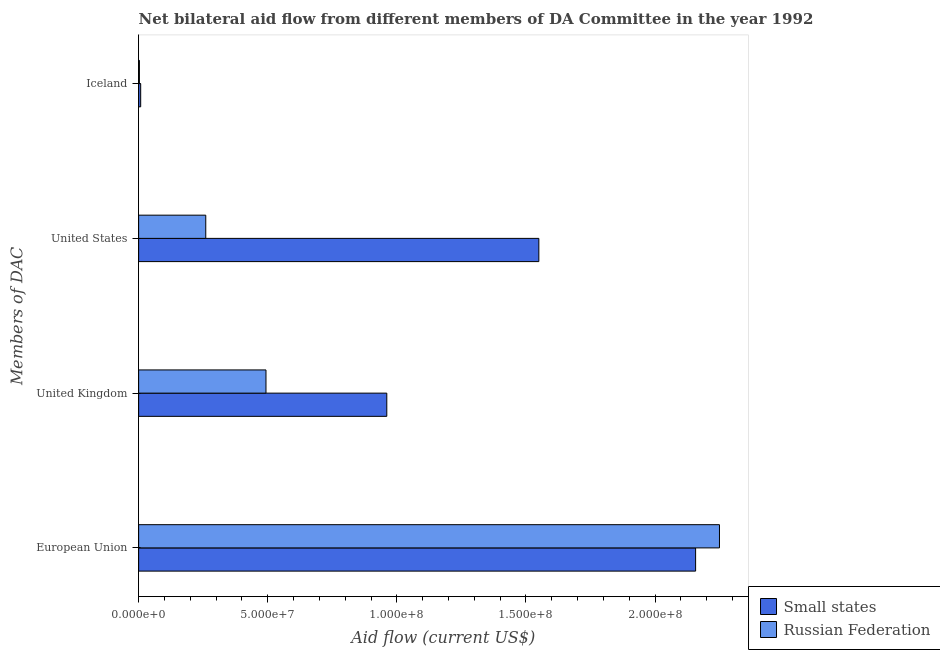How many groups of bars are there?
Ensure brevity in your answer.  4. Are the number of bars on each tick of the Y-axis equal?
Keep it short and to the point. Yes. How many bars are there on the 2nd tick from the top?
Keep it short and to the point. 2. What is the label of the 1st group of bars from the top?
Provide a short and direct response. Iceland. What is the amount of aid given by uk in Russian Federation?
Offer a very short reply. 4.93e+07. Across all countries, what is the maximum amount of aid given by iceland?
Provide a succinct answer. 8.00e+05. Across all countries, what is the minimum amount of aid given by uk?
Your response must be concise. 4.93e+07. In which country was the amount of aid given by eu maximum?
Your answer should be compact. Russian Federation. In which country was the amount of aid given by uk minimum?
Give a very brief answer. Russian Federation. What is the total amount of aid given by uk in the graph?
Make the answer very short. 1.45e+08. What is the difference between the amount of aid given by eu in Russian Federation and that in Small states?
Your answer should be compact. 9.24e+06. What is the difference between the amount of aid given by eu in Russian Federation and the amount of aid given by us in Small states?
Your answer should be compact. 7.00e+07. What is the average amount of aid given by iceland per country?
Make the answer very short. 5.50e+05. What is the difference between the amount of aid given by eu and amount of aid given by iceland in Russian Federation?
Ensure brevity in your answer.  2.25e+08. In how many countries, is the amount of aid given by eu greater than 220000000 US$?
Ensure brevity in your answer.  1. What is the ratio of the amount of aid given by iceland in Russian Federation to that in Small states?
Your answer should be compact. 0.38. What is the difference between the highest and the second highest amount of aid given by us?
Provide a short and direct response. 1.29e+08. What is the difference between the highest and the lowest amount of aid given by uk?
Your answer should be compact. 4.68e+07. In how many countries, is the amount of aid given by uk greater than the average amount of aid given by uk taken over all countries?
Make the answer very short. 1. What does the 1st bar from the top in United States represents?
Your answer should be compact. Russian Federation. What does the 2nd bar from the bottom in Iceland represents?
Provide a short and direct response. Russian Federation. How many countries are there in the graph?
Your response must be concise. 2. Are the values on the major ticks of X-axis written in scientific E-notation?
Ensure brevity in your answer.  Yes. Does the graph contain grids?
Offer a terse response. No. Where does the legend appear in the graph?
Your response must be concise. Bottom right. How many legend labels are there?
Your answer should be very brief. 2. What is the title of the graph?
Provide a succinct answer. Net bilateral aid flow from different members of DA Committee in the year 1992. What is the label or title of the X-axis?
Provide a short and direct response. Aid flow (current US$). What is the label or title of the Y-axis?
Offer a very short reply. Members of DAC. What is the Aid flow (current US$) of Small states in European Union?
Offer a terse response. 2.16e+08. What is the Aid flow (current US$) in Russian Federation in European Union?
Your response must be concise. 2.25e+08. What is the Aid flow (current US$) in Small states in United Kingdom?
Make the answer very short. 9.61e+07. What is the Aid flow (current US$) of Russian Federation in United Kingdom?
Keep it short and to the point. 4.93e+07. What is the Aid flow (current US$) of Small states in United States?
Your answer should be compact. 1.55e+08. What is the Aid flow (current US$) in Russian Federation in United States?
Offer a terse response. 2.60e+07. Across all Members of DAC, what is the maximum Aid flow (current US$) in Small states?
Provide a succinct answer. 2.16e+08. Across all Members of DAC, what is the maximum Aid flow (current US$) in Russian Federation?
Your answer should be compact. 2.25e+08. Across all Members of DAC, what is the minimum Aid flow (current US$) of Small states?
Offer a terse response. 8.00e+05. What is the total Aid flow (current US$) of Small states in the graph?
Offer a terse response. 4.68e+08. What is the total Aid flow (current US$) in Russian Federation in the graph?
Ensure brevity in your answer.  3.01e+08. What is the difference between the Aid flow (current US$) in Small states in European Union and that in United Kingdom?
Provide a succinct answer. 1.20e+08. What is the difference between the Aid flow (current US$) in Russian Federation in European Union and that in United Kingdom?
Your response must be concise. 1.76e+08. What is the difference between the Aid flow (current US$) in Small states in European Union and that in United States?
Keep it short and to the point. 6.07e+07. What is the difference between the Aid flow (current US$) of Russian Federation in European Union and that in United States?
Provide a succinct answer. 1.99e+08. What is the difference between the Aid flow (current US$) in Small states in European Union and that in Iceland?
Keep it short and to the point. 2.15e+08. What is the difference between the Aid flow (current US$) of Russian Federation in European Union and that in Iceland?
Offer a very short reply. 2.25e+08. What is the difference between the Aid flow (current US$) of Small states in United Kingdom and that in United States?
Keep it short and to the point. -5.89e+07. What is the difference between the Aid flow (current US$) in Russian Federation in United Kingdom and that in United States?
Your answer should be very brief. 2.33e+07. What is the difference between the Aid flow (current US$) of Small states in United Kingdom and that in Iceland?
Give a very brief answer. 9.53e+07. What is the difference between the Aid flow (current US$) of Russian Federation in United Kingdom and that in Iceland?
Your answer should be compact. 4.90e+07. What is the difference between the Aid flow (current US$) of Small states in United States and that in Iceland?
Provide a short and direct response. 1.54e+08. What is the difference between the Aid flow (current US$) in Russian Federation in United States and that in Iceland?
Give a very brief answer. 2.57e+07. What is the difference between the Aid flow (current US$) in Small states in European Union and the Aid flow (current US$) in Russian Federation in United Kingdom?
Give a very brief answer. 1.66e+08. What is the difference between the Aid flow (current US$) of Small states in European Union and the Aid flow (current US$) of Russian Federation in United States?
Your answer should be compact. 1.90e+08. What is the difference between the Aid flow (current US$) of Small states in European Union and the Aid flow (current US$) of Russian Federation in Iceland?
Offer a very short reply. 2.15e+08. What is the difference between the Aid flow (current US$) of Small states in United Kingdom and the Aid flow (current US$) of Russian Federation in United States?
Your answer should be compact. 7.01e+07. What is the difference between the Aid flow (current US$) of Small states in United Kingdom and the Aid flow (current US$) of Russian Federation in Iceland?
Offer a very short reply. 9.58e+07. What is the difference between the Aid flow (current US$) in Small states in United States and the Aid flow (current US$) in Russian Federation in Iceland?
Your answer should be compact. 1.55e+08. What is the average Aid flow (current US$) of Small states per Members of DAC?
Offer a terse response. 1.17e+08. What is the average Aid flow (current US$) of Russian Federation per Members of DAC?
Offer a very short reply. 7.51e+07. What is the difference between the Aid flow (current US$) of Small states and Aid flow (current US$) of Russian Federation in European Union?
Your answer should be very brief. -9.24e+06. What is the difference between the Aid flow (current US$) in Small states and Aid flow (current US$) in Russian Federation in United Kingdom?
Keep it short and to the point. 4.68e+07. What is the difference between the Aid flow (current US$) of Small states and Aid flow (current US$) of Russian Federation in United States?
Provide a succinct answer. 1.29e+08. What is the ratio of the Aid flow (current US$) of Small states in European Union to that in United Kingdom?
Your response must be concise. 2.24. What is the ratio of the Aid flow (current US$) of Russian Federation in European Union to that in United Kingdom?
Your answer should be compact. 4.56. What is the ratio of the Aid flow (current US$) of Small states in European Union to that in United States?
Your response must be concise. 1.39. What is the ratio of the Aid flow (current US$) of Russian Federation in European Union to that in United States?
Make the answer very short. 8.65. What is the ratio of the Aid flow (current US$) of Small states in European Union to that in Iceland?
Your answer should be very brief. 269.64. What is the ratio of the Aid flow (current US$) in Russian Federation in European Union to that in Iceland?
Your response must be concise. 749.83. What is the ratio of the Aid flow (current US$) in Small states in United Kingdom to that in United States?
Provide a succinct answer. 0.62. What is the ratio of the Aid flow (current US$) of Russian Federation in United Kingdom to that in United States?
Offer a very short reply. 1.9. What is the ratio of the Aid flow (current US$) of Small states in United Kingdom to that in Iceland?
Your response must be concise. 120.14. What is the ratio of the Aid flow (current US$) of Russian Federation in United Kingdom to that in Iceland?
Your answer should be compact. 164.4. What is the ratio of the Aid flow (current US$) of Small states in United States to that in Iceland?
Your response must be concise. 193.75. What is the ratio of the Aid flow (current US$) in Russian Federation in United States to that in Iceland?
Provide a short and direct response. 86.67. What is the difference between the highest and the second highest Aid flow (current US$) in Small states?
Make the answer very short. 6.07e+07. What is the difference between the highest and the second highest Aid flow (current US$) in Russian Federation?
Give a very brief answer. 1.76e+08. What is the difference between the highest and the lowest Aid flow (current US$) in Small states?
Make the answer very short. 2.15e+08. What is the difference between the highest and the lowest Aid flow (current US$) of Russian Federation?
Offer a very short reply. 2.25e+08. 